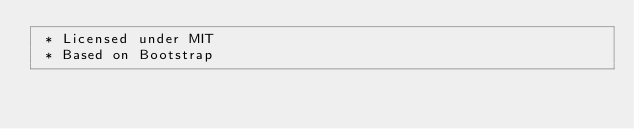<code> <loc_0><loc_0><loc_500><loc_500><_CSS_> * Licensed under MIT
 * Based on Bootstrap</code> 